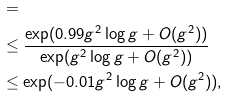Convert formula to latex. <formula><loc_0><loc_0><loc_500><loc_500>& = { } \\ & \leq \frac { \exp ( 0 . 9 9 g ^ { 2 } \log g + O ( g ^ { 2 } ) ) } { \exp ( g ^ { 2 } \log g + O ( g ^ { 2 } ) ) } \\ & \leq \exp ( - 0 . 0 1 g ^ { 2 } \log g + O ( g ^ { 2 } ) ) ,</formula> 